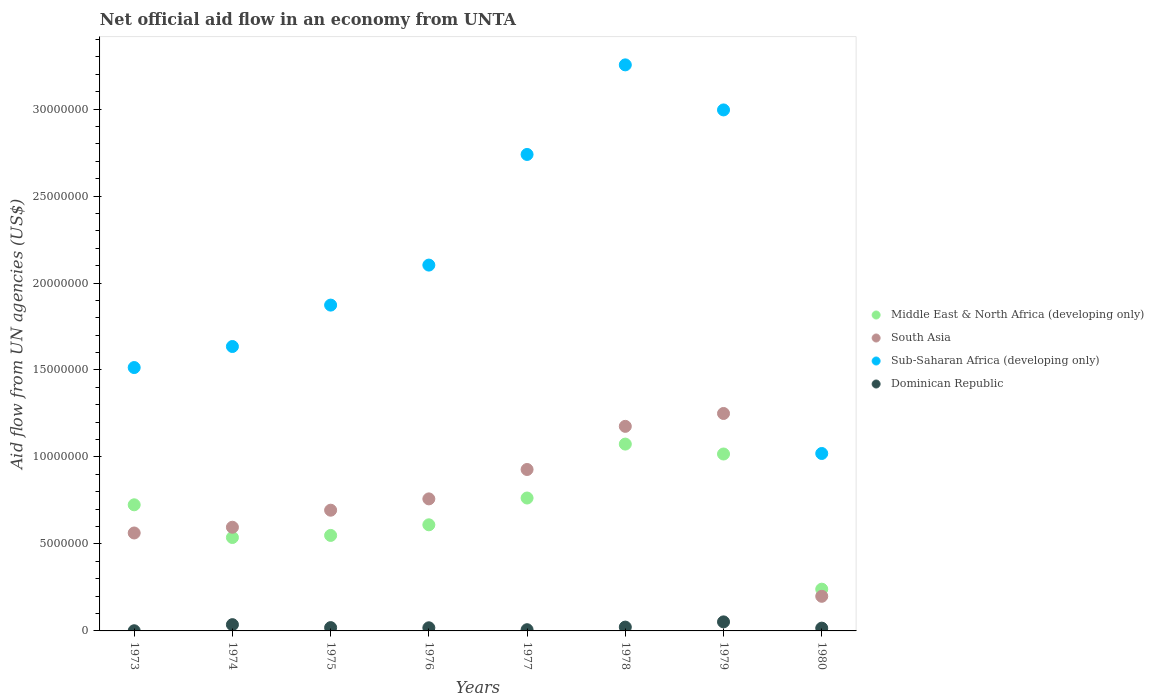How many different coloured dotlines are there?
Provide a succinct answer. 4. What is the net official aid flow in Sub-Saharan Africa (developing only) in 1979?
Your response must be concise. 3.00e+07. Across all years, what is the maximum net official aid flow in South Asia?
Your answer should be very brief. 1.25e+07. Across all years, what is the minimum net official aid flow in Sub-Saharan Africa (developing only)?
Ensure brevity in your answer.  1.02e+07. In which year was the net official aid flow in Middle East & North Africa (developing only) maximum?
Your response must be concise. 1978. In which year was the net official aid flow in Dominican Republic minimum?
Provide a succinct answer. 1973. What is the total net official aid flow in Dominican Republic in the graph?
Provide a short and direct response. 1.71e+06. What is the difference between the net official aid flow in Dominican Republic in 1975 and that in 1979?
Your response must be concise. -3.30e+05. What is the difference between the net official aid flow in Sub-Saharan Africa (developing only) in 1980 and the net official aid flow in Middle East & North Africa (developing only) in 1977?
Your answer should be compact. 2.56e+06. What is the average net official aid flow in South Asia per year?
Keep it short and to the point. 7.71e+06. In the year 1980, what is the difference between the net official aid flow in Dominican Republic and net official aid flow in South Asia?
Make the answer very short. -1.83e+06. In how many years, is the net official aid flow in Middle East & North Africa (developing only) greater than 10000000 US$?
Give a very brief answer. 2. What is the ratio of the net official aid flow in South Asia in 1974 to that in 1980?
Make the answer very short. 2.99. What is the difference between the highest and the second highest net official aid flow in Sub-Saharan Africa (developing only)?
Give a very brief answer. 2.59e+06. What is the difference between the highest and the lowest net official aid flow in Middle East & North Africa (developing only)?
Give a very brief answer. 8.34e+06. Is the sum of the net official aid flow in Middle East & North Africa (developing only) in 1973 and 1978 greater than the maximum net official aid flow in Dominican Republic across all years?
Keep it short and to the point. Yes. Is it the case that in every year, the sum of the net official aid flow in South Asia and net official aid flow in Dominican Republic  is greater than the sum of net official aid flow in Sub-Saharan Africa (developing only) and net official aid flow in Middle East & North Africa (developing only)?
Keep it short and to the point. No. Is the net official aid flow in Dominican Republic strictly greater than the net official aid flow in Middle East & North Africa (developing only) over the years?
Provide a short and direct response. No. Is the net official aid flow in Dominican Republic strictly less than the net official aid flow in South Asia over the years?
Offer a terse response. Yes. How many years are there in the graph?
Your answer should be very brief. 8. Are the values on the major ticks of Y-axis written in scientific E-notation?
Your answer should be very brief. No. How many legend labels are there?
Make the answer very short. 4. What is the title of the graph?
Your answer should be very brief. Net official aid flow in an economy from UNTA. Does "Korea (Democratic)" appear as one of the legend labels in the graph?
Give a very brief answer. No. What is the label or title of the Y-axis?
Give a very brief answer. Aid flow from UN agencies (US$). What is the Aid flow from UN agencies (US$) of Middle East & North Africa (developing only) in 1973?
Provide a succinct answer. 7.25e+06. What is the Aid flow from UN agencies (US$) in South Asia in 1973?
Your answer should be very brief. 5.63e+06. What is the Aid flow from UN agencies (US$) of Sub-Saharan Africa (developing only) in 1973?
Give a very brief answer. 1.51e+07. What is the Aid flow from UN agencies (US$) of Middle East & North Africa (developing only) in 1974?
Provide a short and direct response. 5.37e+06. What is the Aid flow from UN agencies (US$) in South Asia in 1974?
Provide a short and direct response. 5.96e+06. What is the Aid flow from UN agencies (US$) in Sub-Saharan Africa (developing only) in 1974?
Your answer should be very brief. 1.64e+07. What is the Aid flow from UN agencies (US$) of Dominican Republic in 1974?
Provide a succinct answer. 3.60e+05. What is the Aid flow from UN agencies (US$) of Middle East & North Africa (developing only) in 1975?
Your answer should be very brief. 5.49e+06. What is the Aid flow from UN agencies (US$) in South Asia in 1975?
Provide a short and direct response. 6.94e+06. What is the Aid flow from UN agencies (US$) in Sub-Saharan Africa (developing only) in 1975?
Your answer should be very brief. 1.87e+07. What is the Aid flow from UN agencies (US$) of Dominican Republic in 1975?
Your response must be concise. 1.90e+05. What is the Aid flow from UN agencies (US$) in Middle East & North Africa (developing only) in 1976?
Provide a succinct answer. 6.10e+06. What is the Aid flow from UN agencies (US$) in South Asia in 1976?
Your response must be concise. 7.59e+06. What is the Aid flow from UN agencies (US$) in Sub-Saharan Africa (developing only) in 1976?
Provide a succinct answer. 2.10e+07. What is the Aid flow from UN agencies (US$) of Middle East & North Africa (developing only) in 1977?
Your answer should be compact. 7.64e+06. What is the Aid flow from UN agencies (US$) in South Asia in 1977?
Ensure brevity in your answer.  9.28e+06. What is the Aid flow from UN agencies (US$) in Sub-Saharan Africa (developing only) in 1977?
Your response must be concise. 2.74e+07. What is the Aid flow from UN agencies (US$) in Middle East & North Africa (developing only) in 1978?
Give a very brief answer. 1.07e+07. What is the Aid flow from UN agencies (US$) in South Asia in 1978?
Make the answer very short. 1.18e+07. What is the Aid flow from UN agencies (US$) in Sub-Saharan Africa (developing only) in 1978?
Make the answer very short. 3.25e+07. What is the Aid flow from UN agencies (US$) of Dominican Republic in 1978?
Provide a succinct answer. 2.20e+05. What is the Aid flow from UN agencies (US$) in Middle East & North Africa (developing only) in 1979?
Your response must be concise. 1.02e+07. What is the Aid flow from UN agencies (US$) in South Asia in 1979?
Ensure brevity in your answer.  1.25e+07. What is the Aid flow from UN agencies (US$) of Sub-Saharan Africa (developing only) in 1979?
Your answer should be compact. 3.00e+07. What is the Aid flow from UN agencies (US$) in Dominican Republic in 1979?
Offer a terse response. 5.20e+05. What is the Aid flow from UN agencies (US$) in Middle East & North Africa (developing only) in 1980?
Your answer should be very brief. 2.40e+06. What is the Aid flow from UN agencies (US$) of South Asia in 1980?
Offer a very short reply. 1.99e+06. What is the Aid flow from UN agencies (US$) in Sub-Saharan Africa (developing only) in 1980?
Provide a short and direct response. 1.02e+07. What is the Aid flow from UN agencies (US$) in Dominican Republic in 1980?
Make the answer very short. 1.60e+05. Across all years, what is the maximum Aid flow from UN agencies (US$) of Middle East & North Africa (developing only)?
Provide a short and direct response. 1.07e+07. Across all years, what is the maximum Aid flow from UN agencies (US$) of South Asia?
Your answer should be compact. 1.25e+07. Across all years, what is the maximum Aid flow from UN agencies (US$) in Sub-Saharan Africa (developing only)?
Your answer should be compact. 3.25e+07. Across all years, what is the maximum Aid flow from UN agencies (US$) of Dominican Republic?
Make the answer very short. 5.20e+05. Across all years, what is the minimum Aid flow from UN agencies (US$) in Middle East & North Africa (developing only)?
Ensure brevity in your answer.  2.40e+06. Across all years, what is the minimum Aid flow from UN agencies (US$) of South Asia?
Offer a very short reply. 1.99e+06. Across all years, what is the minimum Aid flow from UN agencies (US$) of Sub-Saharan Africa (developing only)?
Give a very brief answer. 1.02e+07. Across all years, what is the minimum Aid flow from UN agencies (US$) of Dominican Republic?
Give a very brief answer. 10000. What is the total Aid flow from UN agencies (US$) in Middle East & North Africa (developing only) in the graph?
Your answer should be very brief. 5.52e+07. What is the total Aid flow from UN agencies (US$) in South Asia in the graph?
Keep it short and to the point. 6.16e+07. What is the total Aid flow from UN agencies (US$) of Sub-Saharan Africa (developing only) in the graph?
Your response must be concise. 1.71e+08. What is the total Aid flow from UN agencies (US$) in Dominican Republic in the graph?
Your response must be concise. 1.71e+06. What is the difference between the Aid flow from UN agencies (US$) of Middle East & North Africa (developing only) in 1973 and that in 1974?
Make the answer very short. 1.88e+06. What is the difference between the Aid flow from UN agencies (US$) of South Asia in 1973 and that in 1974?
Make the answer very short. -3.30e+05. What is the difference between the Aid flow from UN agencies (US$) of Sub-Saharan Africa (developing only) in 1973 and that in 1974?
Ensure brevity in your answer.  -1.21e+06. What is the difference between the Aid flow from UN agencies (US$) of Dominican Republic in 1973 and that in 1974?
Ensure brevity in your answer.  -3.50e+05. What is the difference between the Aid flow from UN agencies (US$) in Middle East & North Africa (developing only) in 1973 and that in 1975?
Your response must be concise. 1.76e+06. What is the difference between the Aid flow from UN agencies (US$) of South Asia in 1973 and that in 1975?
Ensure brevity in your answer.  -1.31e+06. What is the difference between the Aid flow from UN agencies (US$) in Sub-Saharan Africa (developing only) in 1973 and that in 1975?
Keep it short and to the point. -3.59e+06. What is the difference between the Aid flow from UN agencies (US$) in Dominican Republic in 1973 and that in 1975?
Your response must be concise. -1.80e+05. What is the difference between the Aid flow from UN agencies (US$) of Middle East & North Africa (developing only) in 1973 and that in 1976?
Give a very brief answer. 1.15e+06. What is the difference between the Aid flow from UN agencies (US$) in South Asia in 1973 and that in 1976?
Keep it short and to the point. -1.96e+06. What is the difference between the Aid flow from UN agencies (US$) of Sub-Saharan Africa (developing only) in 1973 and that in 1976?
Your response must be concise. -5.89e+06. What is the difference between the Aid flow from UN agencies (US$) of Dominican Republic in 1973 and that in 1976?
Provide a short and direct response. -1.70e+05. What is the difference between the Aid flow from UN agencies (US$) in Middle East & North Africa (developing only) in 1973 and that in 1977?
Provide a short and direct response. -3.90e+05. What is the difference between the Aid flow from UN agencies (US$) in South Asia in 1973 and that in 1977?
Your answer should be very brief. -3.65e+06. What is the difference between the Aid flow from UN agencies (US$) in Sub-Saharan Africa (developing only) in 1973 and that in 1977?
Your answer should be compact. -1.22e+07. What is the difference between the Aid flow from UN agencies (US$) in Dominican Republic in 1973 and that in 1977?
Provide a succinct answer. -6.00e+04. What is the difference between the Aid flow from UN agencies (US$) of Middle East & North Africa (developing only) in 1973 and that in 1978?
Your answer should be compact. -3.49e+06. What is the difference between the Aid flow from UN agencies (US$) in South Asia in 1973 and that in 1978?
Ensure brevity in your answer.  -6.13e+06. What is the difference between the Aid flow from UN agencies (US$) of Sub-Saharan Africa (developing only) in 1973 and that in 1978?
Your response must be concise. -1.74e+07. What is the difference between the Aid flow from UN agencies (US$) in Middle East & North Africa (developing only) in 1973 and that in 1979?
Your answer should be compact. -2.92e+06. What is the difference between the Aid flow from UN agencies (US$) in South Asia in 1973 and that in 1979?
Provide a succinct answer. -6.87e+06. What is the difference between the Aid flow from UN agencies (US$) of Sub-Saharan Africa (developing only) in 1973 and that in 1979?
Your answer should be compact. -1.48e+07. What is the difference between the Aid flow from UN agencies (US$) in Dominican Republic in 1973 and that in 1979?
Your answer should be very brief. -5.10e+05. What is the difference between the Aid flow from UN agencies (US$) of Middle East & North Africa (developing only) in 1973 and that in 1980?
Give a very brief answer. 4.85e+06. What is the difference between the Aid flow from UN agencies (US$) of South Asia in 1973 and that in 1980?
Provide a short and direct response. 3.64e+06. What is the difference between the Aid flow from UN agencies (US$) in Sub-Saharan Africa (developing only) in 1973 and that in 1980?
Your answer should be compact. 4.94e+06. What is the difference between the Aid flow from UN agencies (US$) in Dominican Republic in 1973 and that in 1980?
Give a very brief answer. -1.50e+05. What is the difference between the Aid flow from UN agencies (US$) of South Asia in 1974 and that in 1975?
Give a very brief answer. -9.80e+05. What is the difference between the Aid flow from UN agencies (US$) in Sub-Saharan Africa (developing only) in 1974 and that in 1975?
Give a very brief answer. -2.38e+06. What is the difference between the Aid flow from UN agencies (US$) of Middle East & North Africa (developing only) in 1974 and that in 1976?
Provide a short and direct response. -7.30e+05. What is the difference between the Aid flow from UN agencies (US$) of South Asia in 1974 and that in 1976?
Your answer should be very brief. -1.63e+06. What is the difference between the Aid flow from UN agencies (US$) in Sub-Saharan Africa (developing only) in 1974 and that in 1976?
Provide a succinct answer. -4.68e+06. What is the difference between the Aid flow from UN agencies (US$) of Middle East & North Africa (developing only) in 1974 and that in 1977?
Offer a very short reply. -2.27e+06. What is the difference between the Aid flow from UN agencies (US$) of South Asia in 1974 and that in 1977?
Your answer should be very brief. -3.32e+06. What is the difference between the Aid flow from UN agencies (US$) in Sub-Saharan Africa (developing only) in 1974 and that in 1977?
Your response must be concise. -1.10e+07. What is the difference between the Aid flow from UN agencies (US$) in Middle East & North Africa (developing only) in 1974 and that in 1978?
Keep it short and to the point. -5.37e+06. What is the difference between the Aid flow from UN agencies (US$) in South Asia in 1974 and that in 1978?
Offer a very short reply. -5.80e+06. What is the difference between the Aid flow from UN agencies (US$) of Sub-Saharan Africa (developing only) in 1974 and that in 1978?
Your answer should be very brief. -1.62e+07. What is the difference between the Aid flow from UN agencies (US$) of Dominican Republic in 1974 and that in 1978?
Your response must be concise. 1.40e+05. What is the difference between the Aid flow from UN agencies (US$) in Middle East & North Africa (developing only) in 1974 and that in 1979?
Give a very brief answer. -4.80e+06. What is the difference between the Aid flow from UN agencies (US$) in South Asia in 1974 and that in 1979?
Keep it short and to the point. -6.54e+06. What is the difference between the Aid flow from UN agencies (US$) in Sub-Saharan Africa (developing only) in 1974 and that in 1979?
Give a very brief answer. -1.36e+07. What is the difference between the Aid flow from UN agencies (US$) of Middle East & North Africa (developing only) in 1974 and that in 1980?
Offer a very short reply. 2.97e+06. What is the difference between the Aid flow from UN agencies (US$) in South Asia in 1974 and that in 1980?
Give a very brief answer. 3.97e+06. What is the difference between the Aid flow from UN agencies (US$) in Sub-Saharan Africa (developing only) in 1974 and that in 1980?
Make the answer very short. 6.15e+06. What is the difference between the Aid flow from UN agencies (US$) of Dominican Republic in 1974 and that in 1980?
Ensure brevity in your answer.  2.00e+05. What is the difference between the Aid flow from UN agencies (US$) in Middle East & North Africa (developing only) in 1975 and that in 1976?
Your answer should be compact. -6.10e+05. What is the difference between the Aid flow from UN agencies (US$) of South Asia in 1975 and that in 1976?
Give a very brief answer. -6.50e+05. What is the difference between the Aid flow from UN agencies (US$) in Sub-Saharan Africa (developing only) in 1975 and that in 1976?
Your response must be concise. -2.30e+06. What is the difference between the Aid flow from UN agencies (US$) in Dominican Republic in 1975 and that in 1976?
Keep it short and to the point. 10000. What is the difference between the Aid flow from UN agencies (US$) of Middle East & North Africa (developing only) in 1975 and that in 1977?
Ensure brevity in your answer.  -2.15e+06. What is the difference between the Aid flow from UN agencies (US$) of South Asia in 1975 and that in 1977?
Offer a terse response. -2.34e+06. What is the difference between the Aid flow from UN agencies (US$) of Sub-Saharan Africa (developing only) in 1975 and that in 1977?
Offer a very short reply. -8.66e+06. What is the difference between the Aid flow from UN agencies (US$) of Dominican Republic in 1975 and that in 1977?
Keep it short and to the point. 1.20e+05. What is the difference between the Aid flow from UN agencies (US$) in Middle East & North Africa (developing only) in 1975 and that in 1978?
Your response must be concise. -5.25e+06. What is the difference between the Aid flow from UN agencies (US$) in South Asia in 1975 and that in 1978?
Your answer should be compact. -4.82e+06. What is the difference between the Aid flow from UN agencies (US$) in Sub-Saharan Africa (developing only) in 1975 and that in 1978?
Provide a succinct answer. -1.38e+07. What is the difference between the Aid flow from UN agencies (US$) of Dominican Republic in 1975 and that in 1978?
Your answer should be compact. -3.00e+04. What is the difference between the Aid flow from UN agencies (US$) of Middle East & North Africa (developing only) in 1975 and that in 1979?
Your response must be concise. -4.68e+06. What is the difference between the Aid flow from UN agencies (US$) of South Asia in 1975 and that in 1979?
Offer a terse response. -5.56e+06. What is the difference between the Aid flow from UN agencies (US$) of Sub-Saharan Africa (developing only) in 1975 and that in 1979?
Provide a succinct answer. -1.12e+07. What is the difference between the Aid flow from UN agencies (US$) in Dominican Republic in 1975 and that in 1979?
Make the answer very short. -3.30e+05. What is the difference between the Aid flow from UN agencies (US$) in Middle East & North Africa (developing only) in 1975 and that in 1980?
Make the answer very short. 3.09e+06. What is the difference between the Aid flow from UN agencies (US$) of South Asia in 1975 and that in 1980?
Offer a very short reply. 4.95e+06. What is the difference between the Aid flow from UN agencies (US$) in Sub-Saharan Africa (developing only) in 1975 and that in 1980?
Ensure brevity in your answer.  8.53e+06. What is the difference between the Aid flow from UN agencies (US$) of Middle East & North Africa (developing only) in 1976 and that in 1977?
Make the answer very short. -1.54e+06. What is the difference between the Aid flow from UN agencies (US$) in South Asia in 1976 and that in 1977?
Your answer should be very brief. -1.69e+06. What is the difference between the Aid flow from UN agencies (US$) of Sub-Saharan Africa (developing only) in 1976 and that in 1977?
Offer a terse response. -6.36e+06. What is the difference between the Aid flow from UN agencies (US$) in Dominican Republic in 1976 and that in 1977?
Your answer should be compact. 1.10e+05. What is the difference between the Aid flow from UN agencies (US$) in Middle East & North Africa (developing only) in 1976 and that in 1978?
Your answer should be very brief. -4.64e+06. What is the difference between the Aid flow from UN agencies (US$) of South Asia in 1976 and that in 1978?
Your response must be concise. -4.17e+06. What is the difference between the Aid flow from UN agencies (US$) in Sub-Saharan Africa (developing only) in 1976 and that in 1978?
Offer a terse response. -1.15e+07. What is the difference between the Aid flow from UN agencies (US$) of Dominican Republic in 1976 and that in 1978?
Ensure brevity in your answer.  -4.00e+04. What is the difference between the Aid flow from UN agencies (US$) of Middle East & North Africa (developing only) in 1976 and that in 1979?
Keep it short and to the point. -4.07e+06. What is the difference between the Aid flow from UN agencies (US$) in South Asia in 1976 and that in 1979?
Provide a short and direct response. -4.91e+06. What is the difference between the Aid flow from UN agencies (US$) in Sub-Saharan Africa (developing only) in 1976 and that in 1979?
Ensure brevity in your answer.  -8.92e+06. What is the difference between the Aid flow from UN agencies (US$) of Middle East & North Africa (developing only) in 1976 and that in 1980?
Give a very brief answer. 3.70e+06. What is the difference between the Aid flow from UN agencies (US$) of South Asia in 1976 and that in 1980?
Offer a terse response. 5.60e+06. What is the difference between the Aid flow from UN agencies (US$) in Sub-Saharan Africa (developing only) in 1976 and that in 1980?
Provide a succinct answer. 1.08e+07. What is the difference between the Aid flow from UN agencies (US$) in Middle East & North Africa (developing only) in 1977 and that in 1978?
Provide a succinct answer. -3.10e+06. What is the difference between the Aid flow from UN agencies (US$) of South Asia in 1977 and that in 1978?
Provide a succinct answer. -2.48e+06. What is the difference between the Aid flow from UN agencies (US$) of Sub-Saharan Africa (developing only) in 1977 and that in 1978?
Provide a short and direct response. -5.15e+06. What is the difference between the Aid flow from UN agencies (US$) of Middle East & North Africa (developing only) in 1977 and that in 1979?
Offer a terse response. -2.53e+06. What is the difference between the Aid flow from UN agencies (US$) in South Asia in 1977 and that in 1979?
Offer a terse response. -3.22e+06. What is the difference between the Aid flow from UN agencies (US$) of Sub-Saharan Africa (developing only) in 1977 and that in 1979?
Provide a short and direct response. -2.56e+06. What is the difference between the Aid flow from UN agencies (US$) in Dominican Republic in 1977 and that in 1979?
Make the answer very short. -4.50e+05. What is the difference between the Aid flow from UN agencies (US$) in Middle East & North Africa (developing only) in 1977 and that in 1980?
Your answer should be very brief. 5.24e+06. What is the difference between the Aid flow from UN agencies (US$) in South Asia in 1977 and that in 1980?
Make the answer very short. 7.29e+06. What is the difference between the Aid flow from UN agencies (US$) in Sub-Saharan Africa (developing only) in 1977 and that in 1980?
Provide a succinct answer. 1.72e+07. What is the difference between the Aid flow from UN agencies (US$) of Dominican Republic in 1977 and that in 1980?
Your answer should be compact. -9.00e+04. What is the difference between the Aid flow from UN agencies (US$) in Middle East & North Africa (developing only) in 1978 and that in 1979?
Offer a terse response. 5.70e+05. What is the difference between the Aid flow from UN agencies (US$) in South Asia in 1978 and that in 1979?
Your answer should be very brief. -7.40e+05. What is the difference between the Aid flow from UN agencies (US$) in Sub-Saharan Africa (developing only) in 1978 and that in 1979?
Give a very brief answer. 2.59e+06. What is the difference between the Aid flow from UN agencies (US$) of Middle East & North Africa (developing only) in 1978 and that in 1980?
Keep it short and to the point. 8.34e+06. What is the difference between the Aid flow from UN agencies (US$) of South Asia in 1978 and that in 1980?
Your response must be concise. 9.77e+06. What is the difference between the Aid flow from UN agencies (US$) of Sub-Saharan Africa (developing only) in 1978 and that in 1980?
Keep it short and to the point. 2.23e+07. What is the difference between the Aid flow from UN agencies (US$) in Middle East & North Africa (developing only) in 1979 and that in 1980?
Ensure brevity in your answer.  7.77e+06. What is the difference between the Aid flow from UN agencies (US$) in South Asia in 1979 and that in 1980?
Keep it short and to the point. 1.05e+07. What is the difference between the Aid flow from UN agencies (US$) of Sub-Saharan Africa (developing only) in 1979 and that in 1980?
Ensure brevity in your answer.  1.98e+07. What is the difference between the Aid flow from UN agencies (US$) in Middle East & North Africa (developing only) in 1973 and the Aid flow from UN agencies (US$) in South Asia in 1974?
Give a very brief answer. 1.29e+06. What is the difference between the Aid flow from UN agencies (US$) of Middle East & North Africa (developing only) in 1973 and the Aid flow from UN agencies (US$) of Sub-Saharan Africa (developing only) in 1974?
Ensure brevity in your answer.  -9.10e+06. What is the difference between the Aid flow from UN agencies (US$) in Middle East & North Africa (developing only) in 1973 and the Aid flow from UN agencies (US$) in Dominican Republic in 1974?
Offer a very short reply. 6.89e+06. What is the difference between the Aid flow from UN agencies (US$) of South Asia in 1973 and the Aid flow from UN agencies (US$) of Sub-Saharan Africa (developing only) in 1974?
Your answer should be compact. -1.07e+07. What is the difference between the Aid flow from UN agencies (US$) of South Asia in 1973 and the Aid flow from UN agencies (US$) of Dominican Republic in 1974?
Provide a succinct answer. 5.27e+06. What is the difference between the Aid flow from UN agencies (US$) in Sub-Saharan Africa (developing only) in 1973 and the Aid flow from UN agencies (US$) in Dominican Republic in 1974?
Your answer should be very brief. 1.48e+07. What is the difference between the Aid flow from UN agencies (US$) in Middle East & North Africa (developing only) in 1973 and the Aid flow from UN agencies (US$) in Sub-Saharan Africa (developing only) in 1975?
Keep it short and to the point. -1.15e+07. What is the difference between the Aid flow from UN agencies (US$) of Middle East & North Africa (developing only) in 1973 and the Aid flow from UN agencies (US$) of Dominican Republic in 1975?
Give a very brief answer. 7.06e+06. What is the difference between the Aid flow from UN agencies (US$) of South Asia in 1973 and the Aid flow from UN agencies (US$) of Sub-Saharan Africa (developing only) in 1975?
Give a very brief answer. -1.31e+07. What is the difference between the Aid flow from UN agencies (US$) in South Asia in 1973 and the Aid flow from UN agencies (US$) in Dominican Republic in 1975?
Make the answer very short. 5.44e+06. What is the difference between the Aid flow from UN agencies (US$) in Sub-Saharan Africa (developing only) in 1973 and the Aid flow from UN agencies (US$) in Dominican Republic in 1975?
Offer a terse response. 1.50e+07. What is the difference between the Aid flow from UN agencies (US$) of Middle East & North Africa (developing only) in 1973 and the Aid flow from UN agencies (US$) of Sub-Saharan Africa (developing only) in 1976?
Provide a succinct answer. -1.38e+07. What is the difference between the Aid flow from UN agencies (US$) of Middle East & North Africa (developing only) in 1973 and the Aid flow from UN agencies (US$) of Dominican Republic in 1976?
Offer a terse response. 7.07e+06. What is the difference between the Aid flow from UN agencies (US$) of South Asia in 1973 and the Aid flow from UN agencies (US$) of Sub-Saharan Africa (developing only) in 1976?
Provide a succinct answer. -1.54e+07. What is the difference between the Aid flow from UN agencies (US$) in South Asia in 1973 and the Aid flow from UN agencies (US$) in Dominican Republic in 1976?
Provide a short and direct response. 5.45e+06. What is the difference between the Aid flow from UN agencies (US$) in Sub-Saharan Africa (developing only) in 1973 and the Aid flow from UN agencies (US$) in Dominican Republic in 1976?
Give a very brief answer. 1.50e+07. What is the difference between the Aid flow from UN agencies (US$) of Middle East & North Africa (developing only) in 1973 and the Aid flow from UN agencies (US$) of South Asia in 1977?
Your answer should be compact. -2.03e+06. What is the difference between the Aid flow from UN agencies (US$) of Middle East & North Africa (developing only) in 1973 and the Aid flow from UN agencies (US$) of Sub-Saharan Africa (developing only) in 1977?
Provide a succinct answer. -2.01e+07. What is the difference between the Aid flow from UN agencies (US$) of Middle East & North Africa (developing only) in 1973 and the Aid flow from UN agencies (US$) of Dominican Republic in 1977?
Your response must be concise. 7.18e+06. What is the difference between the Aid flow from UN agencies (US$) of South Asia in 1973 and the Aid flow from UN agencies (US$) of Sub-Saharan Africa (developing only) in 1977?
Offer a very short reply. -2.18e+07. What is the difference between the Aid flow from UN agencies (US$) of South Asia in 1973 and the Aid flow from UN agencies (US$) of Dominican Republic in 1977?
Provide a succinct answer. 5.56e+06. What is the difference between the Aid flow from UN agencies (US$) in Sub-Saharan Africa (developing only) in 1973 and the Aid flow from UN agencies (US$) in Dominican Republic in 1977?
Give a very brief answer. 1.51e+07. What is the difference between the Aid flow from UN agencies (US$) in Middle East & North Africa (developing only) in 1973 and the Aid flow from UN agencies (US$) in South Asia in 1978?
Offer a very short reply. -4.51e+06. What is the difference between the Aid flow from UN agencies (US$) in Middle East & North Africa (developing only) in 1973 and the Aid flow from UN agencies (US$) in Sub-Saharan Africa (developing only) in 1978?
Your response must be concise. -2.53e+07. What is the difference between the Aid flow from UN agencies (US$) in Middle East & North Africa (developing only) in 1973 and the Aid flow from UN agencies (US$) in Dominican Republic in 1978?
Offer a terse response. 7.03e+06. What is the difference between the Aid flow from UN agencies (US$) of South Asia in 1973 and the Aid flow from UN agencies (US$) of Sub-Saharan Africa (developing only) in 1978?
Provide a short and direct response. -2.69e+07. What is the difference between the Aid flow from UN agencies (US$) of South Asia in 1973 and the Aid flow from UN agencies (US$) of Dominican Republic in 1978?
Ensure brevity in your answer.  5.41e+06. What is the difference between the Aid flow from UN agencies (US$) in Sub-Saharan Africa (developing only) in 1973 and the Aid flow from UN agencies (US$) in Dominican Republic in 1978?
Your answer should be very brief. 1.49e+07. What is the difference between the Aid flow from UN agencies (US$) in Middle East & North Africa (developing only) in 1973 and the Aid flow from UN agencies (US$) in South Asia in 1979?
Offer a very short reply. -5.25e+06. What is the difference between the Aid flow from UN agencies (US$) in Middle East & North Africa (developing only) in 1973 and the Aid flow from UN agencies (US$) in Sub-Saharan Africa (developing only) in 1979?
Your answer should be compact. -2.27e+07. What is the difference between the Aid flow from UN agencies (US$) in Middle East & North Africa (developing only) in 1973 and the Aid flow from UN agencies (US$) in Dominican Republic in 1979?
Offer a very short reply. 6.73e+06. What is the difference between the Aid flow from UN agencies (US$) in South Asia in 1973 and the Aid flow from UN agencies (US$) in Sub-Saharan Africa (developing only) in 1979?
Offer a very short reply. -2.43e+07. What is the difference between the Aid flow from UN agencies (US$) of South Asia in 1973 and the Aid flow from UN agencies (US$) of Dominican Republic in 1979?
Your answer should be compact. 5.11e+06. What is the difference between the Aid flow from UN agencies (US$) in Sub-Saharan Africa (developing only) in 1973 and the Aid flow from UN agencies (US$) in Dominican Republic in 1979?
Offer a very short reply. 1.46e+07. What is the difference between the Aid flow from UN agencies (US$) in Middle East & North Africa (developing only) in 1973 and the Aid flow from UN agencies (US$) in South Asia in 1980?
Provide a succinct answer. 5.26e+06. What is the difference between the Aid flow from UN agencies (US$) in Middle East & North Africa (developing only) in 1973 and the Aid flow from UN agencies (US$) in Sub-Saharan Africa (developing only) in 1980?
Make the answer very short. -2.95e+06. What is the difference between the Aid flow from UN agencies (US$) in Middle East & North Africa (developing only) in 1973 and the Aid flow from UN agencies (US$) in Dominican Republic in 1980?
Provide a succinct answer. 7.09e+06. What is the difference between the Aid flow from UN agencies (US$) in South Asia in 1973 and the Aid flow from UN agencies (US$) in Sub-Saharan Africa (developing only) in 1980?
Provide a short and direct response. -4.57e+06. What is the difference between the Aid flow from UN agencies (US$) in South Asia in 1973 and the Aid flow from UN agencies (US$) in Dominican Republic in 1980?
Your answer should be very brief. 5.47e+06. What is the difference between the Aid flow from UN agencies (US$) in Sub-Saharan Africa (developing only) in 1973 and the Aid flow from UN agencies (US$) in Dominican Republic in 1980?
Your response must be concise. 1.50e+07. What is the difference between the Aid flow from UN agencies (US$) in Middle East & North Africa (developing only) in 1974 and the Aid flow from UN agencies (US$) in South Asia in 1975?
Ensure brevity in your answer.  -1.57e+06. What is the difference between the Aid flow from UN agencies (US$) of Middle East & North Africa (developing only) in 1974 and the Aid flow from UN agencies (US$) of Sub-Saharan Africa (developing only) in 1975?
Provide a succinct answer. -1.34e+07. What is the difference between the Aid flow from UN agencies (US$) in Middle East & North Africa (developing only) in 1974 and the Aid flow from UN agencies (US$) in Dominican Republic in 1975?
Offer a very short reply. 5.18e+06. What is the difference between the Aid flow from UN agencies (US$) in South Asia in 1974 and the Aid flow from UN agencies (US$) in Sub-Saharan Africa (developing only) in 1975?
Your response must be concise. -1.28e+07. What is the difference between the Aid flow from UN agencies (US$) in South Asia in 1974 and the Aid flow from UN agencies (US$) in Dominican Republic in 1975?
Make the answer very short. 5.77e+06. What is the difference between the Aid flow from UN agencies (US$) of Sub-Saharan Africa (developing only) in 1974 and the Aid flow from UN agencies (US$) of Dominican Republic in 1975?
Your response must be concise. 1.62e+07. What is the difference between the Aid flow from UN agencies (US$) in Middle East & North Africa (developing only) in 1974 and the Aid flow from UN agencies (US$) in South Asia in 1976?
Ensure brevity in your answer.  -2.22e+06. What is the difference between the Aid flow from UN agencies (US$) in Middle East & North Africa (developing only) in 1974 and the Aid flow from UN agencies (US$) in Sub-Saharan Africa (developing only) in 1976?
Provide a succinct answer. -1.57e+07. What is the difference between the Aid flow from UN agencies (US$) of Middle East & North Africa (developing only) in 1974 and the Aid flow from UN agencies (US$) of Dominican Republic in 1976?
Your answer should be very brief. 5.19e+06. What is the difference between the Aid flow from UN agencies (US$) of South Asia in 1974 and the Aid flow from UN agencies (US$) of Sub-Saharan Africa (developing only) in 1976?
Make the answer very short. -1.51e+07. What is the difference between the Aid flow from UN agencies (US$) of South Asia in 1974 and the Aid flow from UN agencies (US$) of Dominican Republic in 1976?
Your answer should be compact. 5.78e+06. What is the difference between the Aid flow from UN agencies (US$) in Sub-Saharan Africa (developing only) in 1974 and the Aid flow from UN agencies (US$) in Dominican Republic in 1976?
Provide a short and direct response. 1.62e+07. What is the difference between the Aid flow from UN agencies (US$) in Middle East & North Africa (developing only) in 1974 and the Aid flow from UN agencies (US$) in South Asia in 1977?
Your answer should be compact. -3.91e+06. What is the difference between the Aid flow from UN agencies (US$) in Middle East & North Africa (developing only) in 1974 and the Aid flow from UN agencies (US$) in Sub-Saharan Africa (developing only) in 1977?
Offer a terse response. -2.20e+07. What is the difference between the Aid flow from UN agencies (US$) in Middle East & North Africa (developing only) in 1974 and the Aid flow from UN agencies (US$) in Dominican Republic in 1977?
Keep it short and to the point. 5.30e+06. What is the difference between the Aid flow from UN agencies (US$) of South Asia in 1974 and the Aid flow from UN agencies (US$) of Sub-Saharan Africa (developing only) in 1977?
Offer a very short reply. -2.14e+07. What is the difference between the Aid flow from UN agencies (US$) of South Asia in 1974 and the Aid flow from UN agencies (US$) of Dominican Republic in 1977?
Your answer should be compact. 5.89e+06. What is the difference between the Aid flow from UN agencies (US$) in Sub-Saharan Africa (developing only) in 1974 and the Aid flow from UN agencies (US$) in Dominican Republic in 1977?
Ensure brevity in your answer.  1.63e+07. What is the difference between the Aid flow from UN agencies (US$) of Middle East & North Africa (developing only) in 1974 and the Aid flow from UN agencies (US$) of South Asia in 1978?
Give a very brief answer. -6.39e+06. What is the difference between the Aid flow from UN agencies (US$) of Middle East & North Africa (developing only) in 1974 and the Aid flow from UN agencies (US$) of Sub-Saharan Africa (developing only) in 1978?
Your answer should be very brief. -2.72e+07. What is the difference between the Aid flow from UN agencies (US$) in Middle East & North Africa (developing only) in 1974 and the Aid flow from UN agencies (US$) in Dominican Republic in 1978?
Your response must be concise. 5.15e+06. What is the difference between the Aid flow from UN agencies (US$) in South Asia in 1974 and the Aid flow from UN agencies (US$) in Sub-Saharan Africa (developing only) in 1978?
Provide a succinct answer. -2.66e+07. What is the difference between the Aid flow from UN agencies (US$) in South Asia in 1974 and the Aid flow from UN agencies (US$) in Dominican Republic in 1978?
Give a very brief answer. 5.74e+06. What is the difference between the Aid flow from UN agencies (US$) in Sub-Saharan Africa (developing only) in 1974 and the Aid flow from UN agencies (US$) in Dominican Republic in 1978?
Offer a very short reply. 1.61e+07. What is the difference between the Aid flow from UN agencies (US$) in Middle East & North Africa (developing only) in 1974 and the Aid flow from UN agencies (US$) in South Asia in 1979?
Offer a very short reply. -7.13e+06. What is the difference between the Aid flow from UN agencies (US$) in Middle East & North Africa (developing only) in 1974 and the Aid flow from UN agencies (US$) in Sub-Saharan Africa (developing only) in 1979?
Your answer should be compact. -2.46e+07. What is the difference between the Aid flow from UN agencies (US$) in Middle East & North Africa (developing only) in 1974 and the Aid flow from UN agencies (US$) in Dominican Republic in 1979?
Your response must be concise. 4.85e+06. What is the difference between the Aid flow from UN agencies (US$) of South Asia in 1974 and the Aid flow from UN agencies (US$) of Sub-Saharan Africa (developing only) in 1979?
Ensure brevity in your answer.  -2.40e+07. What is the difference between the Aid flow from UN agencies (US$) of South Asia in 1974 and the Aid flow from UN agencies (US$) of Dominican Republic in 1979?
Offer a terse response. 5.44e+06. What is the difference between the Aid flow from UN agencies (US$) of Sub-Saharan Africa (developing only) in 1974 and the Aid flow from UN agencies (US$) of Dominican Republic in 1979?
Keep it short and to the point. 1.58e+07. What is the difference between the Aid flow from UN agencies (US$) of Middle East & North Africa (developing only) in 1974 and the Aid flow from UN agencies (US$) of South Asia in 1980?
Make the answer very short. 3.38e+06. What is the difference between the Aid flow from UN agencies (US$) of Middle East & North Africa (developing only) in 1974 and the Aid flow from UN agencies (US$) of Sub-Saharan Africa (developing only) in 1980?
Give a very brief answer. -4.83e+06. What is the difference between the Aid flow from UN agencies (US$) of Middle East & North Africa (developing only) in 1974 and the Aid flow from UN agencies (US$) of Dominican Republic in 1980?
Keep it short and to the point. 5.21e+06. What is the difference between the Aid flow from UN agencies (US$) of South Asia in 1974 and the Aid flow from UN agencies (US$) of Sub-Saharan Africa (developing only) in 1980?
Offer a terse response. -4.24e+06. What is the difference between the Aid flow from UN agencies (US$) in South Asia in 1974 and the Aid flow from UN agencies (US$) in Dominican Republic in 1980?
Provide a succinct answer. 5.80e+06. What is the difference between the Aid flow from UN agencies (US$) of Sub-Saharan Africa (developing only) in 1974 and the Aid flow from UN agencies (US$) of Dominican Republic in 1980?
Make the answer very short. 1.62e+07. What is the difference between the Aid flow from UN agencies (US$) of Middle East & North Africa (developing only) in 1975 and the Aid flow from UN agencies (US$) of South Asia in 1976?
Your answer should be compact. -2.10e+06. What is the difference between the Aid flow from UN agencies (US$) of Middle East & North Africa (developing only) in 1975 and the Aid flow from UN agencies (US$) of Sub-Saharan Africa (developing only) in 1976?
Your answer should be compact. -1.55e+07. What is the difference between the Aid flow from UN agencies (US$) in Middle East & North Africa (developing only) in 1975 and the Aid flow from UN agencies (US$) in Dominican Republic in 1976?
Offer a terse response. 5.31e+06. What is the difference between the Aid flow from UN agencies (US$) of South Asia in 1975 and the Aid flow from UN agencies (US$) of Sub-Saharan Africa (developing only) in 1976?
Offer a terse response. -1.41e+07. What is the difference between the Aid flow from UN agencies (US$) of South Asia in 1975 and the Aid flow from UN agencies (US$) of Dominican Republic in 1976?
Give a very brief answer. 6.76e+06. What is the difference between the Aid flow from UN agencies (US$) of Sub-Saharan Africa (developing only) in 1975 and the Aid flow from UN agencies (US$) of Dominican Republic in 1976?
Provide a succinct answer. 1.86e+07. What is the difference between the Aid flow from UN agencies (US$) in Middle East & North Africa (developing only) in 1975 and the Aid flow from UN agencies (US$) in South Asia in 1977?
Keep it short and to the point. -3.79e+06. What is the difference between the Aid flow from UN agencies (US$) in Middle East & North Africa (developing only) in 1975 and the Aid flow from UN agencies (US$) in Sub-Saharan Africa (developing only) in 1977?
Provide a short and direct response. -2.19e+07. What is the difference between the Aid flow from UN agencies (US$) of Middle East & North Africa (developing only) in 1975 and the Aid flow from UN agencies (US$) of Dominican Republic in 1977?
Your response must be concise. 5.42e+06. What is the difference between the Aid flow from UN agencies (US$) in South Asia in 1975 and the Aid flow from UN agencies (US$) in Sub-Saharan Africa (developing only) in 1977?
Provide a short and direct response. -2.04e+07. What is the difference between the Aid flow from UN agencies (US$) in South Asia in 1975 and the Aid flow from UN agencies (US$) in Dominican Republic in 1977?
Provide a short and direct response. 6.87e+06. What is the difference between the Aid flow from UN agencies (US$) in Sub-Saharan Africa (developing only) in 1975 and the Aid flow from UN agencies (US$) in Dominican Republic in 1977?
Your answer should be very brief. 1.87e+07. What is the difference between the Aid flow from UN agencies (US$) of Middle East & North Africa (developing only) in 1975 and the Aid flow from UN agencies (US$) of South Asia in 1978?
Make the answer very short. -6.27e+06. What is the difference between the Aid flow from UN agencies (US$) of Middle East & North Africa (developing only) in 1975 and the Aid flow from UN agencies (US$) of Sub-Saharan Africa (developing only) in 1978?
Your answer should be very brief. -2.70e+07. What is the difference between the Aid flow from UN agencies (US$) in Middle East & North Africa (developing only) in 1975 and the Aid flow from UN agencies (US$) in Dominican Republic in 1978?
Offer a very short reply. 5.27e+06. What is the difference between the Aid flow from UN agencies (US$) in South Asia in 1975 and the Aid flow from UN agencies (US$) in Sub-Saharan Africa (developing only) in 1978?
Provide a short and direct response. -2.56e+07. What is the difference between the Aid flow from UN agencies (US$) of South Asia in 1975 and the Aid flow from UN agencies (US$) of Dominican Republic in 1978?
Your answer should be very brief. 6.72e+06. What is the difference between the Aid flow from UN agencies (US$) of Sub-Saharan Africa (developing only) in 1975 and the Aid flow from UN agencies (US$) of Dominican Republic in 1978?
Provide a succinct answer. 1.85e+07. What is the difference between the Aid flow from UN agencies (US$) in Middle East & North Africa (developing only) in 1975 and the Aid flow from UN agencies (US$) in South Asia in 1979?
Your answer should be very brief. -7.01e+06. What is the difference between the Aid flow from UN agencies (US$) in Middle East & North Africa (developing only) in 1975 and the Aid flow from UN agencies (US$) in Sub-Saharan Africa (developing only) in 1979?
Provide a succinct answer. -2.45e+07. What is the difference between the Aid flow from UN agencies (US$) in Middle East & North Africa (developing only) in 1975 and the Aid flow from UN agencies (US$) in Dominican Republic in 1979?
Make the answer very short. 4.97e+06. What is the difference between the Aid flow from UN agencies (US$) of South Asia in 1975 and the Aid flow from UN agencies (US$) of Sub-Saharan Africa (developing only) in 1979?
Provide a short and direct response. -2.30e+07. What is the difference between the Aid flow from UN agencies (US$) in South Asia in 1975 and the Aid flow from UN agencies (US$) in Dominican Republic in 1979?
Give a very brief answer. 6.42e+06. What is the difference between the Aid flow from UN agencies (US$) in Sub-Saharan Africa (developing only) in 1975 and the Aid flow from UN agencies (US$) in Dominican Republic in 1979?
Give a very brief answer. 1.82e+07. What is the difference between the Aid flow from UN agencies (US$) in Middle East & North Africa (developing only) in 1975 and the Aid flow from UN agencies (US$) in South Asia in 1980?
Your response must be concise. 3.50e+06. What is the difference between the Aid flow from UN agencies (US$) in Middle East & North Africa (developing only) in 1975 and the Aid flow from UN agencies (US$) in Sub-Saharan Africa (developing only) in 1980?
Offer a terse response. -4.71e+06. What is the difference between the Aid flow from UN agencies (US$) in Middle East & North Africa (developing only) in 1975 and the Aid flow from UN agencies (US$) in Dominican Republic in 1980?
Your response must be concise. 5.33e+06. What is the difference between the Aid flow from UN agencies (US$) of South Asia in 1975 and the Aid flow from UN agencies (US$) of Sub-Saharan Africa (developing only) in 1980?
Your answer should be very brief. -3.26e+06. What is the difference between the Aid flow from UN agencies (US$) in South Asia in 1975 and the Aid flow from UN agencies (US$) in Dominican Republic in 1980?
Your answer should be very brief. 6.78e+06. What is the difference between the Aid flow from UN agencies (US$) in Sub-Saharan Africa (developing only) in 1975 and the Aid flow from UN agencies (US$) in Dominican Republic in 1980?
Provide a short and direct response. 1.86e+07. What is the difference between the Aid flow from UN agencies (US$) in Middle East & North Africa (developing only) in 1976 and the Aid flow from UN agencies (US$) in South Asia in 1977?
Ensure brevity in your answer.  -3.18e+06. What is the difference between the Aid flow from UN agencies (US$) in Middle East & North Africa (developing only) in 1976 and the Aid flow from UN agencies (US$) in Sub-Saharan Africa (developing only) in 1977?
Your response must be concise. -2.13e+07. What is the difference between the Aid flow from UN agencies (US$) of Middle East & North Africa (developing only) in 1976 and the Aid flow from UN agencies (US$) of Dominican Republic in 1977?
Give a very brief answer. 6.03e+06. What is the difference between the Aid flow from UN agencies (US$) in South Asia in 1976 and the Aid flow from UN agencies (US$) in Sub-Saharan Africa (developing only) in 1977?
Offer a very short reply. -1.98e+07. What is the difference between the Aid flow from UN agencies (US$) of South Asia in 1976 and the Aid flow from UN agencies (US$) of Dominican Republic in 1977?
Provide a short and direct response. 7.52e+06. What is the difference between the Aid flow from UN agencies (US$) in Sub-Saharan Africa (developing only) in 1976 and the Aid flow from UN agencies (US$) in Dominican Republic in 1977?
Ensure brevity in your answer.  2.10e+07. What is the difference between the Aid flow from UN agencies (US$) in Middle East & North Africa (developing only) in 1976 and the Aid flow from UN agencies (US$) in South Asia in 1978?
Your answer should be compact. -5.66e+06. What is the difference between the Aid flow from UN agencies (US$) in Middle East & North Africa (developing only) in 1976 and the Aid flow from UN agencies (US$) in Sub-Saharan Africa (developing only) in 1978?
Offer a terse response. -2.64e+07. What is the difference between the Aid flow from UN agencies (US$) of Middle East & North Africa (developing only) in 1976 and the Aid flow from UN agencies (US$) of Dominican Republic in 1978?
Your answer should be very brief. 5.88e+06. What is the difference between the Aid flow from UN agencies (US$) in South Asia in 1976 and the Aid flow from UN agencies (US$) in Sub-Saharan Africa (developing only) in 1978?
Give a very brief answer. -2.50e+07. What is the difference between the Aid flow from UN agencies (US$) in South Asia in 1976 and the Aid flow from UN agencies (US$) in Dominican Republic in 1978?
Give a very brief answer. 7.37e+06. What is the difference between the Aid flow from UN agencies (US$) in Sub-Saharan Africa (developing only) in 1976 and the Aid flow from UN agencies (US$) in Dominican Republic in 1978?
Your answer should be very brief. 2.08e+07. What is the difference between the Aid flow from UN agencies (US$) in Middle East & North Africa (developing only) in 1976 and the Aid flow from UN agencies (US$) in South Asia in 1979?
Make the answer very short. -6.40e+06. What is the difference between the Aid flow from UN agencies (US$) in Middle East & North Africa (developing only) in 1976 and the Aid flow from UN agencies (US$) in Sub-Saharan Africa (developing only) in 1979?
Provide a short and direct response. -2.38e+07. What is the difference between the Aid flow from UN agencies (US$) in Middle East & North Africa (developing only) in 1976 and the Aid flow from UN agencies (US$) in Dominican Republic in 1979?
Make the answer very short. 5.58e+06. What is the difference between the Aid flow from UN agencies (US$) in South Asia in 1976 and the Aid flow from UN agencies (US$) in Sub-Saharan Africa (developing only) in 1979?
Provide a succinct answer. -2.24e+07. What is the difference between the Aid flow from UN agencies (US$) in South Asia in 1976 and the Aid flow from UN agencies (US$) in Dominican Republic in 1979?
Provide a succinct answer. 7.07e+06. What is the difference between the Aid flow from UN agencies (US$) of Sub-Saharan Africa (developing only) in 1976 and the Aid flow from UN agencies (US$) of Dominican Republic in 1979?
Offer a terse response. 2.05e+07. What is the difference between the Aid flow from UN agencies (US$) in Middle East & North Africa (developing only) in 1976 and the Aid flow from UN agencies (US$) in South Asia in 1980?
Your answer should be very brief. 4.11e+06. What is the difference between the Aid flow from UN agencies (US$) of Middle East & North Africa (developing only) in 1976 and the Aid flow from UN agencies (US$) of Sub-Saharan Africa (developing only) in 1980?
Offer a very short reply. -4.10e+06. What is the difference between the Aid flow from UN agencies (US$) in Middle East & North Africa (developing only) in 1976 and the Aid flow from UN agencies (US$) in Dominican Republic in 1980?
Keep it short and to the point. 5.94e+06. What is the difference between the Aid flow from UN agencies (US$) of South Asia in 1976 and the Aid flow from UN agencies (US$) of Sub-Saharan Africa (developing only) in 1980?
Ensure brevity in your answer.  -2.61e+06. What is the difference between the Aid flow from UN agencies (US$) in South Asia in 1976 and the Aid flow from UN agencies (US$) in Dominican Republic in 1980?
Your answer should be compact. 7.43e+06. What is the difference between the Aid flow from UN agencies (US$) of Sub-Saharan Africa (developing only) in 1976 and the Aid flow from UN agencies (US$) of Dominican Republic in 1980?
Keep it short and to the point. 2.09e+07. What is the difference between the Aid flow from UN agencies (US$) in Middle East & North Africa (developing only) in 1977 and the Aid flow from UN agencies (US$) in South Asia in 1978?
Your response must be concise. -4.12e+06. What is the difference between the Aid flow from UN agencies (US$) of Middle East & North Africa (developing only) in 1977 and the Aid flow from UN agencies (US$) of Sub-Saharan Africa (developing only) in 1978?
Provide a succinct answer. -2.49e+07. What is the difference between the Aid flow from UN agencies (US$) in Middle East & North Africa (developing only) in 1977 and the Aid flow from UN agencies (US$) in Dominican Republic in 1978?
Your response must be concise. 7.42e+06. What is the difference between the Aid flow from UN agencies (US$) of South Asia in 1977 and the Aid flow from UN agencies (US$) of Sub-Saharan Africa (developing only) in 1978?
Your answer should be very brief. -2.33e+07. What is the difference between the Aid flow from UN agencies (US$) in South Asia in 1977 and the Aid flow from UN agencies (US$) in Dominican Republic in 1978?
Provide a short and direct response. 9.06e+06. What is the difference between the Aid flow from UN agencies (US$) in Sub-Saharan Africa (developing only) in 1977 and the Aid flow from UN agencies (US$) in Dominican Republic in 1978?
Provide a short and direct response. 2.72e+07. What is the difference between the Aid flow from UN agencies (US$) of Middle East & North Africa (developing only) in 1977 and the Aid flow from UN agencies (US$) of South Asia in 1979?
Offer a terse response. -4.86e+06. What is the difference between the Aid flow from UN agencies (US$) in Middle East & North Africa (developing only) in 1977 and the Aid flow from UN agencies (US$) in Sub-Saharan Africa (developing only) in 1979?
Provide a short and direct response. -2.23e+07. What is the difference between the Aid flow from UN agencies (US$) of Middle East & North Africa (developing only) in 1977 and the Aid flow from UN agencies (US$) of Dominican Republic in 1979?
Provide a succinct answer. 7.12e+06. What is the difference between the Aid flow from UN agencies (US$) in South Asia in 1977 and the Aid flow from UN agencies (US$) in Sub-Saharan Africa (developing only) in 1979?
Ensure brevity in your answer.  -2.07e+07. What is the difference between the Aid flow from UN agencies (US$) of South Asia in 1977 and the Aid flow from UN agencies (US$) of Dominican Republic in 1979?
Offer a terse response. 8.76e+06. What is the difference between the Aid flow from UN agencies (US$) of Sub-Saharan Africa (developing only) in 1977 and the Aid flow from UN agencies (US$) of Dominican Republic in 1979?
Provide a succinct answer. 2.69e+07. What is the difference between the Aid flow from UN agencies (US$) of Middle East & North Africa (developing only) in 1977 and the Aid flow from UN agencies (US$) of South Asia in 1980?
Your response must be concise. 5.65e+06. What is the difference between the Aid flow from UN agencies (US$) of Middle East & North Africa (developing only) in 1977 and the Aid flow from UN agencies (US$) of Sub-Saharan Africa (developing only) in 1980?
Give a very brief answer. -2.56e+06. What is the difference between the Aid flow from UN agencies (US$) of Middle East & North Africa (developing only) in 1977 and the Aid flow from UN agencies (US$) of Dominican Republic in 1980?
Give a very brief answer. 7.48e+06. What is the difference between the Aid flow from UN agencies (US$) in South Asia in 1977 and the Aid flow from UN agencies (US$) in Sub-Saharan Africa (developing only) in 1980?
Your answer should be compact. -9.20e+05. What is the difference between the Aid flow from UN agencies (US$) of South Asia in 1977 and the Aid flow from UN agencies (US$) of Dominican Republic in 1980?
Your answer should be compact. 9.12e+06. What is the difference between the Aid flow from UN agencies (US$) of Sub-Saharan Africa (developing only) in 1977 and the Aid flow from UN agencies (US$) of Dominican Republic in 1980?
Provide a succinct answer. 2.72e+07. What is the difference between the Aid flow from UN agencies (US$) of Middle East & North Africa (developing only) in 1978 and the Aid flow from UN agencies (US$) of South Asia in 1979?
Offer a very short reply. -1.76e+06. What is the difference between the Aid flow from UN agencies (US$) of Middle East & North Africa (developing only) in 1978 and the Aid flow from UN agencies (US$) of Sub-Saharan Africa (developing only) in 1979?
Offer a very short reply. -1.92e+07. What is the difference between the Aid flow from UN agencies (US$) of Middle East & North Africa (developing only) in 1978 and the Aid flow from UN agencies (US$) of Dominican Republic in 1979?
Your answer should be very brief. 1.02e+07. What is the difference between the Aid flow from UN agencies (US$) in South Asia in 1978 and the Aid flow from UN agencies (US$) in Sub-Saharan Africa (developing only) in 1979?
Make the answer very short. -1.82e+07. What is the difference between the Aid flow from UN agencies (US$) of South Asia in 1978 and the Aid flow from UN agencies (US$) of Dominican Republic in 1979?
Keep it short and to the point. 1.12e+07. What is the difference between the Aid flow from UN agencies (US$) in Sub-Saharan Africa (developing only) in 1978 and the Aid flow from UN agencies (US$) in Dominican Republic in 1979?
Provide a short and direct response. 3.20e+07. What is the difference between the Aid flow from UN agencies (US$) in Middle East & North Africa (developing only) in 1978 and the Aid flow from UN agencies (US$) in South Asia in 1980?
Provide a succinct answer. 8.75e+06. What is the difference between the Aid flow from UN agencies (US$) of Middle East & North Africa (developing only) in 1978 and the Aid flow from UN agencies (US$) of Sub-Saharan Africa (developing only) in 1980?
Provide a succinct answer. 5.40e+05. What is the difference between the Aid flow from UN agencies (US$) of Middle East & North Africa (developing only) in 1978 and the Aid flow from UN agencies (US$) of Dominican Republic in 1980?
Keep it short and to the point. 1.06e+07. What is the difference between the Aid flow from UN agencies (US$) in South Asia in 1978 and the Aid flow from UN agencies (US$) in Sub-Saharan Africa (developing only) in 1980?
Offer a very short reply. 1.56e+06. What is the difference between the Aid flow from UN agencies (US$) of South Asia in 1978 and the Aid flow from UN agencies (US$) of Dominican Republic in 1980?
Make the answer very short. 1.16e+07. What is the difference between the Aid flow from UN agencies (US$) in Sub-Saharan Africa (developing only) in 1978 and the Aid flow from UN agencies (US$) in Dominican Republic in 1980?
Provide a short and direct response. 3.24e+07. What is the difference between the Aid flow from UN agencies (US$) in Middle East & North Africa (developing only) in 1979 and the Aid flow from UN agencies (US$) in South Asia in 1980?
Offer a terse response. 8.18e+06. What is the difference between the Aid flow from UN agencies (US$) in Middle East & North Africa (developing only) in 1979 and the Aid flow from UN agencies (US$) in Sub-Saharan Africa (developing only) in 1980?
Offer a terse response. -3.00e+04. What is the difference between the Aid flow from UN agencies (US$) of Middle East & North Africa (developing only) in 1979 and the Aid flow from UN agencies (US$) of Dominican Republic in 1980?
Offer a very short reply. 1.00e+07. What is the difference between the Aid flow from UN agencies (US$) in South Asia in 1979 and the Aid flow from UN agencies (US$) in Sub-Saharan Africa (developing only) in 1980?
Make the answer very short. 2.30e+06. What is the difference between the Aid flow from UN agencies (US$) of South Asia in 1979 and the Aid flow from UN agencies (US$) of Dominican Republic in 1980?
Offer a very short reply. 1.23e+07. What is the difference between the Aid flow from UN agencies (US$) in Sub-Saharan Africa (developing only) in 1979 and the Aid flow from UN agencies (US$) in Dominican Republic in 1980?
Give a very brief answer. 2.98e+07. What is the average Aid flow from UN agencies (US$) in Middle East & North Africa (developing only) per year?
Provide a succinct answer. 6.90e+06. What is the average Aid flow from UN agencies (US$) in South Asia per year?
Give a very brief answer. 7.71e+06. What is the average Aid flow from UN agencies (US$) in Sub-Saharan Africa (developing only) per year?
Provide a short and direct response. 2.14e+07. What is the average Aid flow from UN agencies (US$) in Dominican Republic per year?
Keep it short and to the point. 2.14e+05. In the year 1973, what is the difference between the Aid flow from UN agencies (US$) in Middle East & North Africa (developing only) and Aid flow from UN agencies (US$) in South Asia?
Your answer should be very brief. 1.62e+06. In the year 1973, what is the difference between the Aid flow from UN agencies (US$) in Middle East & North Africa (developing only) and Aid flow from UN agencies (US$) in Sub-Saharan Africa (developing only)?
Offer a terse response. -7.89e+06. In the year 1973, what is the difference between the Aid flow from UN agencies (US$) in Middle East & North Africa (developing only) and Aid flow from UN agencies (US$) in Dominican Republic?
Keep it short and to the point. 7.24e+06. In the year 1973, what is the difference between the Aid flow from UN agencies (US$) of South Asia and Aid flow from UN agencies (US$) of Sub-Saharan Africa (developing only)?
Your answer should be compact. -9.51e+06. In the year 1973, what is the difference between the Aid flow from UN agencies (US$) in South Asia and Aid flow from UN agencies (US$) in Dominican Republic?
Provide a succinct answer. 5.62e+06. In the year 1973, what is the difference between the Aid flow from UN agencies (US$) of Sub-Saharan Africa (developing only) and Aid flow from UN agencies (US$) of Dominican Republic?
Your response must be concise. 1.51e+07. In the year 1974, what is the difference between the Aid flow from UN agencies (US$) of Middle East & North Africa (developing only) and Aid flow from UN agencies (US$) of South Asia?
Your response must be concise. -5.90e+05. In the year 1974, what is the difference between the Aid flow from UN agencies (US$) in Middle East & North Africa (developing only) and Aid flow from UN agencies (US$) in Sub-Saharan Africa (developing only)?
Provide a short and direct response. -1.10e+07. In the year 1974, what is the difference between the Aid flow from UN agencies (US$) in Middle East & North Africa (developing only) and Aid flow from UN agencies (US$) in Dominican Republic?
Provide a short and direct response. 5.01e+06. In the year 1974, what is the difference between the Aid flow from UN agencies (US$) in South Asia and Aid flow from UN agencies (US$) in Sub-Saharan Africa (developing only)?
Offer a very short reply. -1.04e+07. In the year 1974, what is the difference between the Aid flow from UN agencies (US$) of South Asia and Aid flow from UN agencies (US$) of Dominican Republic?
Your answer should be very brief. 5.60e+06. In the year 1974, what is the difference between the Aid flow from UN agencies (US$) in Sub-Saharan Africa (developing only) and Aid flow from UN agencies (US$) in Dominican Republic?
Your answer should be compact. 1.60e+07. In the year 1975, what is the difference between the Aid flow from UN agencies (US$) of Middle East & North Africa (developing only) and Aid flow from UN agencies (US$) of South Asia?
Offer a very short reply. -1.45e+06. In the year 1975, what is the difference between the Aid flow from UN agencies (US$) in Middle East & North Africa (developing only) and Aid flow from UN agencies (US$) in Sub-Saharan Africa (developing only)?
Your answer should be compact. -1.32e+07. In the year 1975, what is the difference between the Aid flow from UN agencies (US$) of Middle East & North Africa (developing only) and Aid flow from UN agencies (US$) of Dominican Republic?
Your answer should be compact. 5.30e+06. In the year 1975, what is the difference between the Aid flow from UN agencies (US$) of South Asia and Aid flow from UN agencies (US$) of Sub-Saharan Africa (developing only)?
Give a very brief answer. -1.18e+07. In the year 1975, what is the difference between the Aid flow from UN agencies (US$) of South Asia and Aid flow from UN agencies (US$) of Dominican Republic?
Make the answer very short. 6.75e+06. In the year 1975, what is the difference between the Aid flow from UN agencies (US$) in Sub-Saharan Africa (developing only) and Aid flow from UN agencies (US$) in Dominican Republic?
Provide a succinct answer. 1.85e+07. In the year 1976, what is the difference between the Aid flow from UN agencies (US$) of Middle East & North Africa (developing only) and Aid flow from UN agencies (US$) of South Asia?
Keep it short and to the point. -1.49e+06. In the year 1976, what is the difference between the Aid flow from UN agencies (US$) of Middle East & North Africa (developing only) and Aid flow from UN agencies (US$) of Sub-Saharan Africa (developing only)?
Your response must be concise. -1.49e+07. In the year 1976, what is the difference between the Aid flow from UN agencies (US$) in Middle East & North Africa (developing only) and Aid flow from UN agencies (US$) in Dominican Republic?
Make the answer very short. 5.92e+06. In the year 1976, what is the difference between the Aid flow from UN agencies (US$) in South Asia and Aid flow from UN agencies (US$) in Sub-Saharan Africa (developing only)?
Give a very brief answer. -1.34e+07. In the year 1976, what is the difference between the Aid flow from UN agencies (US$) of South Asia and Aid flow from UN agencies (US$) of Dominican Republic?
Provide a short and direct response. 7.41e+06. In the year 1976, what is the difference between the Aid flow from UN agencies (US$) of Sub-Saharan Africa (developing only) and Aid flow from UN agencies (US$) of Dominican Republic?
Your answer should be very brief. 2.08e+07. In the year 1977, what is the difference between the Aid flow from UN agencies (US$) of Middle East & North Africa (developing only) and Aid flow from UN agencies (US$) of South Asia?
Offer a terse response. -1.64e+06. In the year 1977, what is the difference between the Aid flow from UN agencies (US$) of Middle East & North Africa (developing only) and Aid flow from UN agencies (US$) of Sub-Saharan Africa (developing only)?
Offer a very short reply. -1.98e+07. In the year 1977, what is the difference between the Aid flow from UN agencies (US$) of Middle East & North Africa (developing only) and Aid flow from UN agencies (US$) of Dominican Republic?
Ensure brevity in your answer.  7.57e+06. In the year 1977, what is the difference between the Aid flow from UN agencies (US$) in South Asia and Aid flow from UN agencies (US$) in Sub-Saharan Africa (developing only)?
Provide a succinct answer. -1.81e+07. In the year 1977, what is the difference between the Aid flow from UN agencies (US$) of South Asia and Aid flow from UN agencies (US$) of Dominican Republic?
Offer a terse response. 9.21e+06. In the year 1977, what is the difference between the Aid flow from UN agencies (US$) in Sub-Saharan Africa (developing only) and Aid flow from UN agencies (US$) in Dominican Republic?
Offer a terse response. 2.73e+07. In the year 1978, what is the difference between the Aid flow from UN agencies (US$) of Middle East & North Africa (developing only) and Aid flow from UN agencies (US$) of South Asia?
Ensure brevity in your answer.  -1.02e+06. In the year 1978, what is the difference between the Aid flow from UN agencies (US$) in Middle East & North Africa (developing only) and Aid flow from UN agencies (US$) in Sub-Saharan Africa (developing only)?
Provide a succinct answer. -2.18e+07. In the year 1978, what is the difference between the Aid flow from UN agencies (US$) of Middle East & North Africa (developing only) and Aid flow from UN agencies (US$) of Dominican Republic?
Ensure brevity in your answer.  1.05e+07. In the year 1978, what is the difference between the Aid flow from UN agencies (US$) of South Asia and Aid flow from UN agencies (US$) of Sub-Saharan Africa (developing only)?
Give a very brief answer. -2.08e+07. In the year 1978, what is the difference between the Aid flow from UN agencies (US$) of South Asia and Aid flow from UN agencies (US$) of Dominican Republic?
Offer a very short reply. 1.15e+07. In the year 1978, what is the difference between the Aid flow from UN agencies (US$) of Sub-Saharan Africa (developing only) and Aid flow from UN agencies (US$) of Dominican Republic?
Offer a terse response. 3.23e+07. In the year 1979, what is the difference between the Aid flow from UN agencies (US$) in Middle East & North Africa (developing only) and Aid flow from UN agencies (US$) in South Asia?
Offer a very short reply. -2.33e+06. In the year 1979, what is the difference between the Aid flow from UN agencies (US$) of Middle East & North Africa (developing only) and Aid flow from UN agencies (US$) of Sub-Saharan Africa (developing only)?
Give a very brief answer. -1.98e+07. In the year 1979, what is the difference between the Aid flow from UN agencies (US$) of Middle East & North Africa (developing only) and Aid flow from UN agencies (US$) of Dominican Republic?
Your response must be concise. 9.65e+06. In the year 1979, what is the difference between the Aid flow from UN agencies (US$) of South Asia and Aid flow from UN agencies (US$) of Sub-Saharan Africa (developing only)?
Make the answer very short. -1.74e+07. In the year 1979, what is the difference between the Aid flow from UN agencies (US$) in South Asia and Aid flow from UN agencies (US$) in Dominican Republic?
Your answer should be compact. 1.20e+07. In the year 1979, what is the difference between the Aid flow from UN agencies (US$) of Sub-Saharan Africa (developing only) and Aid flow from UN agencies (US$) of Dominican Republic?
Your answer should be very brief. 2.94e+07. In the year 1980, what is the difference between the Aid flow from UN agencies (US$) in Middle East & North Africa (developing only) and Aid flow from UN agencies (US$) in South Asia?
Ensure brevity in your answer.  4.10e+05. In the year 1980, what is the difference between the Aid flow from UN agencies (US$) of Middle East & North Africa (developing only) and Aid flow from UN agencies (US$) of Sub-Saharan Africa (developing only)?
Your response must be concise. -7.80e+06. In the year 1980, what is the difference between the Aid flow from UN agencies (US$) of Middle East & North Africa (developing only) and Aid flow from UN agencies (US$) of Dominican Republic?
Keep it short and to the point. 2.24e+06. In the year 1980, what is the difference between the Aid flow from UN agencies (US$) in South Asia and Aid flow from UN agencies (US$) in Sub-Saharan Africa (developing only)?
Make the answer very short. -8.21e+06. In the year 1980, what is the difference between the Aid flow from UN agencies (US$) of South Asia and Aid flow from UN agencies (US$) of Dominican Republic?
Provide a succinct answer. 1.83e+06. In the year 1980, what is the difference between the Aid flow from UN agencies (US$) of Sub-Saharan Africa (developing only) and Aid flow from UN agencies (US$) of Dominican Republic?
Make the answer very short. 1.00e+07. What is the ratio of the Aid flow from UN agencies (US$) of Middle East & North Africa (developing only) in 1973 to that in 1974?
Provide a succinct answer. 1.35. What is the ratio of the Aid flow from UN agencies (US$) in South Asia in 1973 to that in 1974?
Provide a short and direct response. 0.94. What is the ratio of the Aid flow from UN agencies (US$) of Sub-Saharan Africa (developing only) in 1973 to that in 1974?
Provide a short and direct response. 0.93. What is the ratio of the Aid flow from UN agencies (US$) in Dominican Republic in 1973 to that in 1974?
Ensure brevity in your answer.  0.03. What is the ratio of the Aid flow from UN agencies (US$) of Middle East & North Africa (developing only) in 1973 to that in 1975?
Offer a very short reply. 1.32. What is the ratio of the Aid flow from UN agencies (US$) of South Asia in 1973 to that in 1975?
Provide a short and direct response. 0.81. What is the ratio of the Aid flow from UN agencies (US$) in Sub-Saharan Africa (developing only) in 1973 to that in 1975?
Your response must be concise. 0.81. What is the ratio of the Aid flow from UN agencies (US$) in Dominican Republic in 1973 to that in 1975?
Give a very brief answer. 0.05. What is the ratio of the Aid flow from UN agencies (US$) in Middle East & North Africa (developing only) in 1973 to that in 1976?
Ensure brevity in your answer.  1.19. What is the ratio of the Aid flow from UN agencies (US$) of South Asia in 1973 to that in 1976?
Make the answer very short. 0.74. What is the ratio of the Aid flow from UN agencies (US$) of Sub-Saharan Africa (developing only) in 1973 to that in 1976?
Ensure brevity in your answer.  0.72. What is the ratio of the Aid flow from UN agencies (US$) of Dominican Republic in 1973 to that in 1976?
Ensure brevity in your answer.  0.06. What is the ratio of the Aid flow from UN agencies (US$) in Middle East & North Africa (developing only) in 1973 to that in 1977?
Provide a short and direct response. 0.95. What is the ratio of the Aid flow from UN agencies (US$) in South Asia in 1973 to that in 1977?
Provide a short and direct response. 0.61. What is the ratio of the Aid flow from UN agencies (US$) of Sub-Saharan Africa (developing only) in 1973 to that in 1977?
Your response must be concise. 0.55. What is the ratio of the Aid flow from UN agencies (US$) in Dominican Republic in 1973 to that in 1977?
Give a very brief answer. 0.14. What is the ratio of the Aid flow from UN agencies (US$) of Middle East & North Africa (developing only) in 1973 to that in 1978?
Provide a short and direct response. 0.68. What is the ratio of the Aid flow from UN agencies (US$) of South Asia in 1973 to that in 1978?
Your answer should be very brief. 0.48. What is the ratio of the Aid flow from UN agencies (US$) of Sub-Saharan Africa (developing only) in 1973 to that in 1978?
Provide a succinct answer. 0.47. What is the ratio of the Aid flow from UN agencies (US$) of Dominican Republic in 1973 to that in 1978?
Provide a short and direct response. 0.05. What is the ratio of the Aid flow from UN agencies (US$) in Middle East & North Africa (developing only) in 1973 to that in 1979?
Provide a succinct answer. 0.71. What is the ratio of the Aid flow from UN agencies (US$) of South Asia in 1973 to that in 1979?
Provide a succinct answer. 0.45. What is the ratio of the Aid flow from UN agencies (US$) of Sub-Saharan Africa (developing only) in 1973 to that in 1979?
Keep it short and to the point. 0.51. What is the ratio of the Aid flow from UN agencies (US$) of Dominican Republic in 1973 to that in 1979?
Your answer should be compact. 0.02. What is the ratio of the Aid flow from UN agencies (US$) in Middle East & North Africa (developing only) in 1973 to that in 1980?
Provide a short and direct response. 3.02. What is the ratio of the Aid flow from UN agencies (US$) of South Asia in 1973 to that in 1980?
Offer a terse response. 2.83. What is the ratio of the Aid flow from UN agencies (US$) of Sub-Saharan Africa (developing only) in 1973 to that in 1980?
Offer a terse response. 1.48. What is the ratio of the Aid flow from UN agencies (US$) of Dominican Republic in 1973 to that in 1980?
Give a very brief answer. 0.06. What is the ratio of the Aid flow from UN agencies (US$) of Middle East & North Africa (developing only) in 1974 to that in 1975?
Your response must be concise. 0.98. What is the ratio of the Aid flow from UN agencies (US$) in South Asia in 1974 to that in 1975?
Give a very brief answer. 0.86. What is the ratio of the Aid flow from UN agencies (US$) of Sub-Saharan Africa (developing only) in 1974 to that in 1975?
Offer a very short reply. 0.87. What is the ratio of the Aid flow from UN agencies (US$) of Dominican Republic in 1974 to that in 1975?
Give a very brief answer. 1.89. What is the ratio of the Aid flow from UN agencies (US$) in Middle East & North Africa (developing only) in 1974 to that in 1976?
Provide a succinct answer. 0.88. What is the ratio of the Aid flow from UN agencies (US$) in South Asia in 1974 to that in 1976?
Offer a terse response. 0.79. What is the ratio of the Aid flow from UN agencies (US$) in Sub-Saharan Africa (developing only) in 1974 to that in 1976?
Give a very brief answer. 0.78. What is the ratio of the Aid flow from UN agencies (US$) in Middle East & North Africa (developing only) in 1974 to that in 1977?
Your answer should be compact. 0.7. What is the ratio of the Aid flow from UN agencies (US$) of South Asia in 1974 to that in 1977?
Your answer should be very brief. 0.64. What is the ratio of the Aid flow from UN agencies (US$) of Sub-Saharan Africa (developing only) in 1974 to that in 1977?
Provide a short and direct response. 0.6. What is the ratio of the Aid flow from UN agencies (US$) in Dominican Republic in 1974 to that in 1977?
Offer a very short reply. 5.14. What is the ratio of the Aid flow from UN agencies (US$) in Middle East & North Africa (developing only) in 1974 to that in 1978?
Provide a short and direct response. 0.5. What is the ratio of the Aid flow from UN agencies (US$) in South Asia in 1974 to that in 1978?
Provide a succinct answer. 0.51. What is the ratio of the Aid flow from UN agencies (US$) of Sub-Saharan Africa (developing only) in 1974 to that in 1978?
Keep it short and to the point. 0.5. What is the ratio of the Aid flow from UN agencies (US$) of Dominican Republic in 1974 to that in 1978?
Make the answer very short. 1.64. What is the ratio of the Aid flow from UN agencies (US$) in Middle East & North Africa (developing only) in 1974 to that in 1979?
Your answer should be compact. 0.53. What is the ratio of the Aid flow from UN agencies (US$) in South Asia in 1974 to that in 1979?
Provide a succinct answer. 0.48. What is the ratio of the Aid flow from UN agencies (US$) of Sub-Saharan Africa (developing only) in 1974 to that in 1979?
Your answer should be compact. 0.55. What is the ratio of the Aid flow from UN agencies (US$) of Dominican Republic in 1974 to that in 1979?
Make the answer very short. 0.69. What is the ratio of the Aid flow from UN agencies (US$) in Middle East & North Africa (developing only) in 1974 to that in 1980?
Offer a terse response. 2.24. What is the ratio of the Aid flow from UN agencies (US$) in South Asia in 1974 to that in 1980?
Make the answer very short. 3. What is the ratio of the Aid flow from UN agencies (US$) of Sub-Saharan Africa (developing only) in 1974 to that in 1980?
Ensure brevity in your answer.  1.6. What is the ratio of the Aid flow from UN agencies (US$) of Dominican Republic in 1974 to that in 1980?
Your answer should be compact. 2.25. What is the ratio of the Aid flow from UN agencies (US$) of Middle East & North Africa (developing only) in 1975 to that in 1976?
Provide a succinct answer. 0.9. What is the ratio of the Aid flow from UN agencies (US$) of South Asia in 1975 to that in 1976?
Provide a succinct answer. 0.91. What is the ratio of the Aid flow from UN agencies (US$) in Sub-Saharan Africa (developing only) in 1975 to that in 1976?
Make the answer very short. 0.89. What is the ratio of the Aid flow from UN agencies (US$) of Dominican Republic in 1975 to that in 1976?
Your answer should be compact. 1.06. What is the ratio of the Aid flow from UN agencies (US$) of Middle East & North Africa (developing only) in 1975 to that in 1977?
Offer a terse response. 0.72. What is the ratio of the Aid flow from UN agencies (US$) in South Asia in 1975 to that in 1977?
Your response must be concise. 0.75. What is the ratio of the Aid flow from UN agencies (US$) of Sub-Saharan Africa (developing only) in 1975 to that in 1977?
Your answer should be very brief. 0.68. What is the ratio of the Aid flow from UN agencies (US$) of Dominican Republic in 1975 to that in 1977?
Provide a short and direct response. 2.71. What is the ratio of the Aid flow from UN agencies (US$) in Middle East & North Africa (developing only) in 1975 to that in 1978?
Offer a very short reply. 0.51. What is the ratio of the Aid flow from UN agencies (US$) in South Asia in 1975 to that in 1978?
Your response must be concise. 0.59. What is the ratio of the Aid flow from UN agencies (US$) in Sub-Saharan Africa (developing only) in 1975 to that in 1978?
Give a very brief answer. 0.58. What is the ratio of the Aid flow from UN agencies (US$) of Dominican Republic in 1975 to that in 1978?
Keep it short and to the point. 0.86. What is the ratio of the Aid flow from UN agencies (US$) of Middle East & North Africa (developing only) in 1975 to that in 1979?
Ensure brevity in your answer.  0.54. What is the ratio of the Aid flow from UN agencies (US$) of South Asia in 1975 to that in 1979?
Provide a succinct answer. 0.56. What is the ratio of the Aid flow from UN agencies (US$) of Sub-Saharan Africa (developing only) in 1975 to that in 1979?
Keep it short and to the point. 0.63. What is the ratio of the Aid flow from UN agencies (US$) of Dominican Republic in 1975 to that in 1979?
Provide a succinct answer. 0.37. What is the ratio of the Aid flow from UN agencies (US$) in Middle East & North Africa (developing only) in 1975 to that in 1980?
Make the answer very short. 2.29. What is the ratio of the Aid flow from UN agencies (US$) of South Asia in 1975 to that in 1980?
Ensure brevity in your answer.  3.49. What is the ratio of the Aid flow from UN agencies (US$) of Sub-Saharan Africa (developing only) in 1975 to that in 1980?
Provide a succinct answer. 1.84. What is the ratio of the Aid flow from UN agencies (US$) of Dominican Republic in 1975 to that in 1980?
Give a very brief answer. 1.19. What is the ratio of the Aid flow from UN agencies (US$) of Middle East & North Africa (developing only) in 1976 to that in 1977?
Offer a very short reply. 0.8. What is the ratio of the Aid flow from UN agencies (US$) in South Asia in 1976 to that in 1977?
Give a very brief answer. 0.82. What is the ratio of the Aid flow from UN agencies (US$) in Sub-Saharan Africa (developing only) in 1976 to that in 1977?
Your answer should be compact. 0.77. What is the ratio of the Aid flow from UN agencies (US$) of Dominican Republic in 1976 to that in 1977?
Keep it short and to the point. 2.57. What is the ratio of the Aid flow from UN agencies (US$) in Middle East & North Africa (developing only) in 1976 to that in 1978?
Provide a succinct answer. 0.57. What is the ratio of the Aid flow from UN agencies (US$) in South Asia in 1976 to that in 1978?
Provide a succinct answer. 0.65. What is the ratio of the Aid flow from UN agencies (US$) of Sub-Saharan Africa (developing only) in 1976 to that in 1978?
Make the answer very short. 0.65. What is the ratio of the Aid flow from UN agencies (US$) in Dominican Republic in 1976 to that in 1978?
Give a very brief answer. 0.82. What is the ratio of the Aid flow from UN agencies (US$) of Middle East & North Africa (developing only) in 1976 to that in 1979?
Ensure brevity in your answer.  0.6. What is the ratio of the Aid flow from UN agencies (US$) in South Asia in 1976 to that in 1979?
Your answer should be compact. 0.61. What is the ratio of the Aid flow from UN agencies (US$) of Sub-Saharan Africa (developing only) in 1976 to that in 1979?
Ensure brevity in your answer.  0.7. What is the ratio of the Aid flow from UN agencies (US$) of Dominican Republic in 1976 to that in 1979?
Ensure brevity in your answer.  0.35. What is the ratio of the Aid flow from UN agencies (US$) in Middle East & North Africa (developing only) in 1976 to that in 1980?
Make the answer very short. 2.54. What is the ratio of the Aid flow from UN agencies (US$) in South Asia in 1976 to that in 1980?
Keep it short and to the point. 3.81. What is the ratio of the Aid flow from UN agencies (US$) of Sub-Saharan Africa (developing only) in 1976 to that in 1980?
Offer a very short reply. 2.06. What is the ratio of the Aid flow from UN agencies (US$) of Dominican Republic in 1976 to that in 1980?
Offer a very short reply. 1.12. What is the ratio of the Aid flow from UN agencies (US$) of Middle East & North Africa (developing only) in 1977 to that in 1978?
Provide a short and direct response. 0.71. What is the ratio of the Aid flow from UN agencies (US$) in South Asia in 1977 to that in 1978?
Your answer should be very brief. 0.79. What is the ratio of the Aid flow from UN agencies (US$) of Sub-Saharan Africa (developing only) in 1977 to that in 1978?
Keep it short and to the point. 0.84. What is the ratio of the Aid flow from UN agencies (US$) of Dominican Republic in 1977 to that in 1978?
Offer a terse response. 0.32. What is the ratio of the Aid flow from UN agencies (US$) in Middle East & North Africa (developing only) in 1977 to that in 1979?
Your answer should be compact. 0.75. What is the ratio of the Aid flow from UN agencies (US$) of South Asia in 1977 to that in 1979?
Give a very brief answer. 0.74. What is the ratio of the Aid flow from UN agencies (US$) of Sub-Saharan Africa (developing only) in 1977 to that in 1979?
Give a very brief answer. 0.91. What is the ratio of the Aid flow from UN agencies (US$) of Dominican Republic in 1977 to that in 1979?
Provide a short and direct response. 0.13. What is the ratio of the Aid flow from UN agencies (US$) of Middle East & North Africa (developing only) in 1977 to that in 1980?
Provide a short and direct response. 3.18. What is the ratio of the Aid flow from UN agencies (US$) in South Asia in 1977 to that in 1980?
Make the answer very short. 4.66. What is the ratio of the Aid flow from UN agencies (US$) of Sub-Saharan Africa (developing only) in 1977 to that in 1980?
Your answer should be compact. 2.69. What is the ratio of the Aid flow from UN agencies (US$) in Dominican Republic in 1977 to that in 1980?
Give a very brief answer. 0.44. What is the ratio of the Aid flow from UN agencies (US$) in Middle East & North Africa (developing only) in 1978 to that in 1979?
Give a very brief answer. 1.06. What is the ratio of the Aid flow from UN agencies (US$) in South Asia in 1978 to that in 1979?
Provide a short and direct response. 0.94. What is the ratio of the Aid flow from UN agencies (US$) in Sub-Saharan Africa (developing only) in 1978 to that in 1979?
Keep it short and to the point. 1.09. What is the ratio of the Aid flow from UN agencies (US$) of Dominican Republic in 1978 to that in 1979?
Provide a succinct answer. 0.42. What is the ratio of the Aid flow from UN agencies (US$) of Middle East & North Africa (developing only) in 1978 to that in 1980?
Offer a terse response. 4.47. What is the ratio of the Aid flow from UN agencies (US$) in South Asia in 1978 to that in 1980?
Provide a succinct answer. 5.91. What is the ratio of the Aid flow from UN agencies (US$) of Sub-Saharan Africa (developing only) in 1978 to that in 1980?
Your response must be concise. 3.19. What is the ratio of the Aid flow from UN agencies (US$) in Dominican Republic in 1978 to that in 1980?
Ensure brevity in your answer.  1.38. What is the ratio of the Aid flow from UN agencies (US$) in Middle East & North Africa (developing only) in 1979 to that in 1980?
Make the answer very short. 4.24. What is the ratio of the Aid flow from UN agencies (US$) of South Asia in 1979 to that in 1980?
Ensure brevity in your answer.  6.28. What is the ratio of the Aid flow from UN agencies (US$) in Sub-Saharan Africa (developing only) in 1979 to that in 1980?
Offer a very short reply. 2.94. What is the difference between the highest and the second highest Aid flow from UN agencies (US$) of Middle East & North Africa (developing only)?
Offer a very short reply. 5.70e+05. What is the difference between the highest and the second highest Aid flow from UN agencies (US$) of South Asia?
Your response must be concise. 7.40e+05. What is the difference between the highest and the second highest Aid flow from UN agencies (US$) in Sub-Saharan Africa (developing only)?
Give a very brief answer. 2.59e+06. What is the difference between the highest and the second highest Aid flow from UN agencies (US$) of Dominican Republic?
Offer a very short reply. 1.60e+05. What is the difference between the highest and the lowest Aid flow from UN agencies (US$) in Middle East & North Africa (developing only)?
Provide a succinct answer. 8.34e+06. What is the difference between the highest and the lowest Aid flow from UN agencies (US$) in South Asia?
Ensure brevity in your answer.  1.05e+07. What is the difference between the highest and the lowest Aid flow from UN agencies (US$) in Sub-Saharan Africa (developing only)?
Make the answer very short. 2.23e+07. What is the difference between the highest and the lowest Aid flow from UN agencies (US$) of Dominican Republic?
Give a very brief answer. 5.10e+05. 